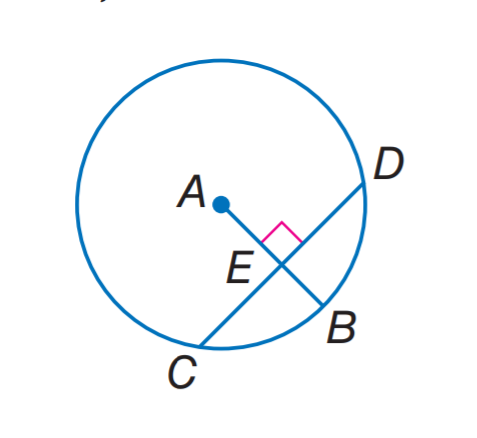Answer the mathemtical geometry problem and directly provide the correct option letter.
Question: In A, the radius is 14 and C D = 22. Find C E.
Choices: A: 7 B: 11 C: 14 D: 22 B 